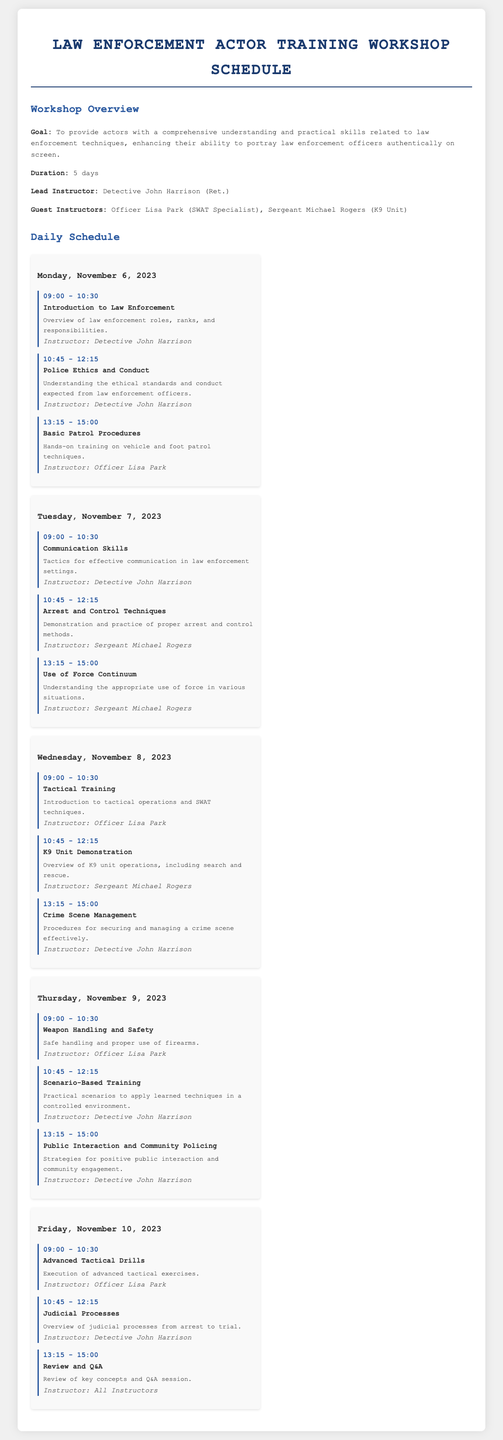What is the goal of the workshop? The goal is to provide actors with a comprehensive understanding and practical skills related to law enforcement techniques.
Answer: Comprehensive understanding and practical skills Who is the lead instructor? The lead instructor is mentioned in the document as Detective John Harrison.
Answer: Detective John Harrison What day does the workshop start? The workshop schedule indicates that it starts on Monday, November 6, 2023.
Answer: Monday, November 6, 2023 How long is the duration of the workshop? The document specifies that the duration is 5 days.
Answer: 5 days What session is scheduled at 09:00 on Tuesday, November 7, 2023? The session scheduled at that time is titled "Communication Skills."
Answer: Communication Skills Who teaches the "Advanced Tactical Drills" session? The instructor for that session is Officer Lisa Park.
Answer: Officer Lisa Park How many sessions are scheduled for Friday, November 10, 2023? The document outlines 3 sessions scheduled for that day.
Answer: 3 sessions Which session covers "Public Interaction and Community Policing"? This session is scheduled on Thursday, November 9, 2023.
Answer: Thursday, November 9, 2023 What is the theme of the session at 10:45 on Wednesday? This session is titled "K9 Unit Demonstration."
Answer: K9 Unit Demonstration 